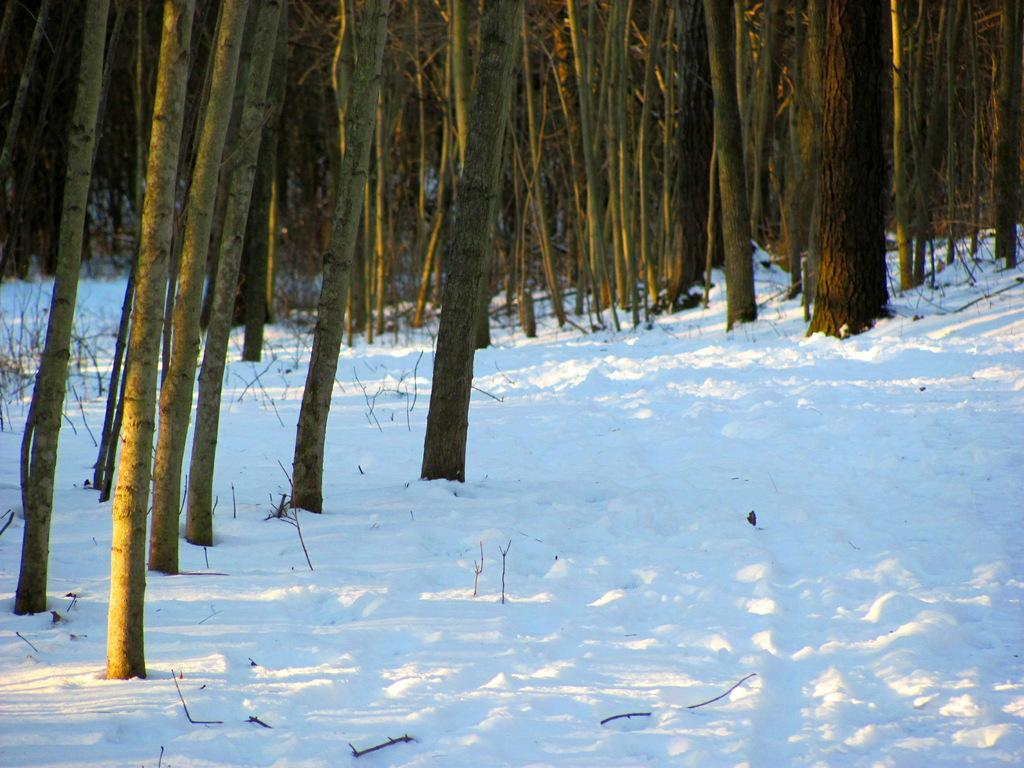What is the primary feature of the landscape in the image? There is snow in the image. What type of natural element can be seen in the image? Tree trunks are visible in the image. What time does the clock show in the image? There is no clock present in the image. How does the land feel under the snow in the image? The image does not provide information about the texture or feel of the land under the snow. 